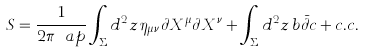Convert formula to latex. <formula><loc_0><loc_0><loc_500><loc_500>S = \frac { 1 } { 2 \pi \ a p } \int _ { \Sigma } d ^ { 2 } z \, \eta _ { \mu \nu } \partial X ^ { \mu } \partial X ^ { \nu } + \int _ { \Sigma } d ^ { 2 } z \, b \bar { \partial } c + c . c .</formula> 